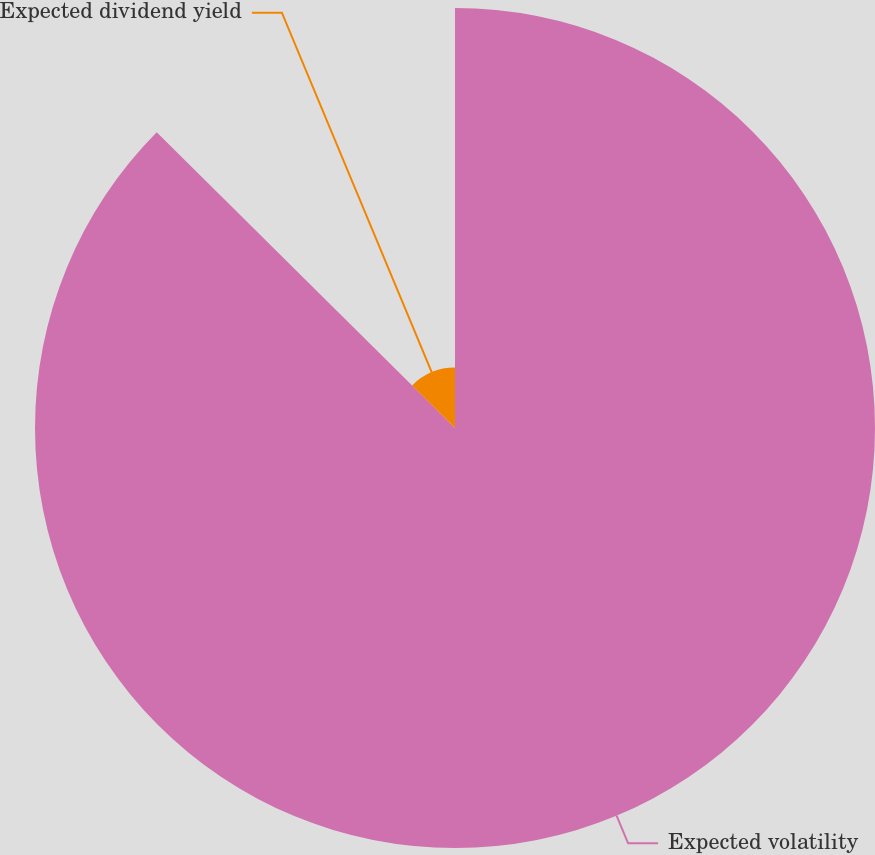Convert chart. <chart><loc_0><loc_0><loc_500><loc_500><pie_chart><fcel>Expected volatility<fcel>Expected dividend yield<nl><fcel>87.43%<fcel>12.57%<nl></chart> 